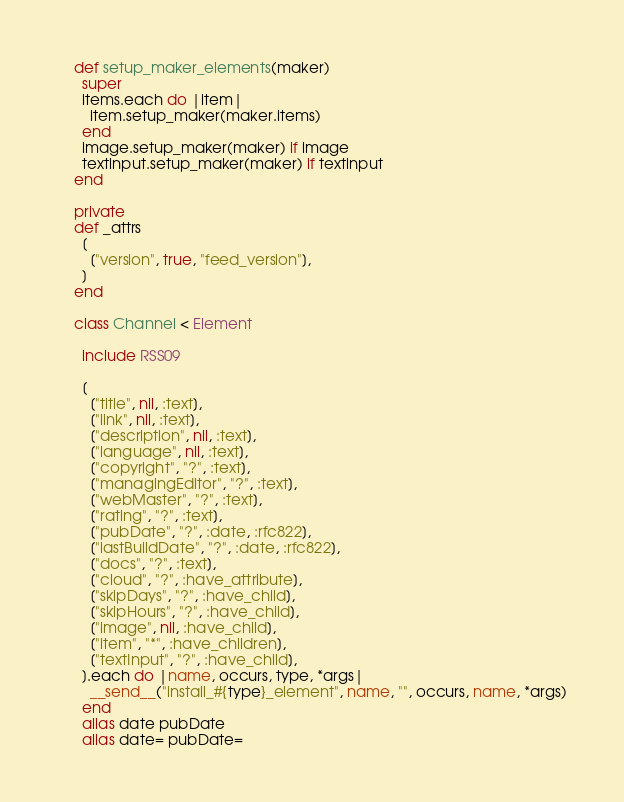Convert code to text. <code><loc_0><loc_0><loc_500><loc_500><_Ruby_>
    def setup_maker_elements(maker)
      super
      items.each do |item|
        item.setup_maker(maker.items)
      end
      image.setup_maker(maker) if image
      textinput.setup_maker(maker) if textinput
    end

    private
    def _attrs
      [
        ["version", true, "feed_version"],
      ]
    end

    class Channel < Element

      include RSS09

      [
        ["title", nil, :text],
        ["link", nil, :text],
        ["description", nil, :text],
        ["language", nil, :text],
        ["copyright", "?", :text],
        ["managingEditor", "?", :text],
        ["webMaster", "?", :text],
        ["rating", "?", :text],
        ["pubDate", "?", :date, :rfc822],
        ["lastBuildDate", "?", :date, :rfc822],
        ["docs", "?", :text],
        ["cloud", "?", :have_attribute],
        ["skipDays", "?", :have_child],
        ["skipHours", "?", :have_child],
        ["image", nil, :have_child],
        ["item", "*", :have_children],
        ["textInput", "?", :have_child],
      ].each do |name, occurs, type, *args|
        __send__("install_#{type}_element", name, "", occurs, name, *args)
      end
      alias date pubDate
      alias date= pubDate=
</code> 